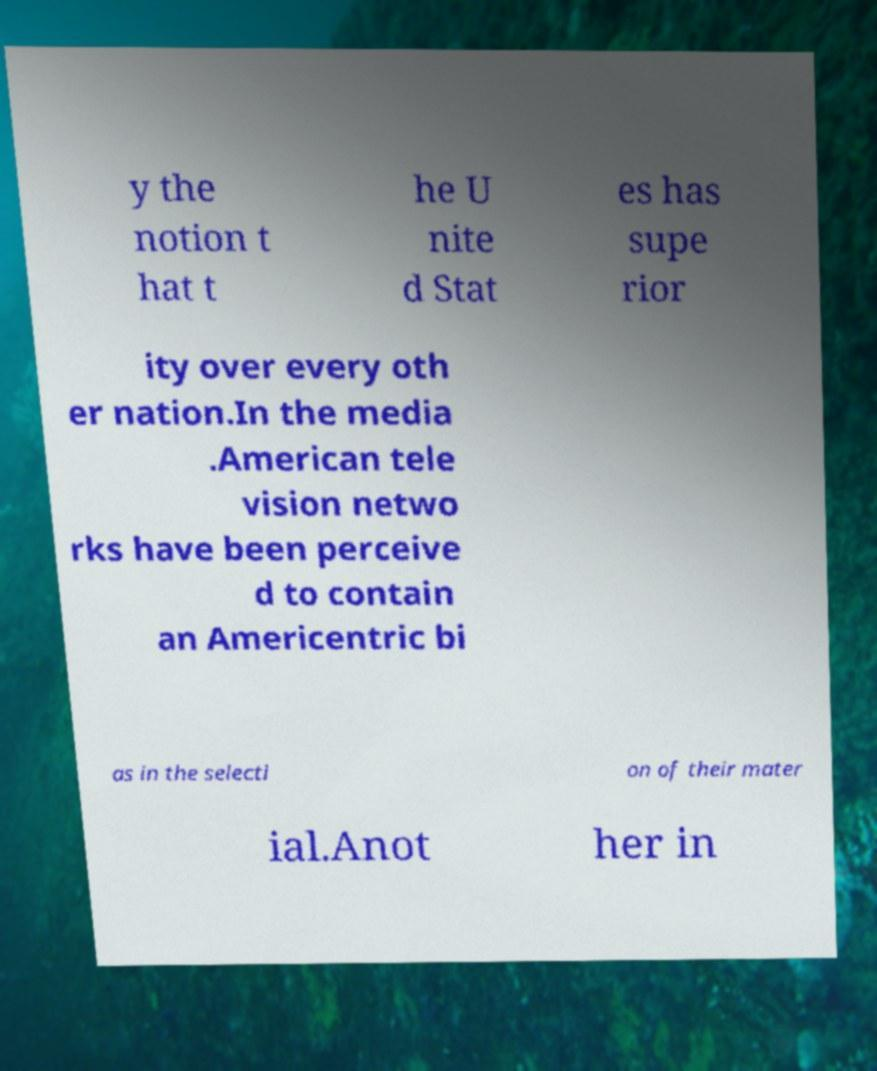For documentation purposes, I need the text within this image transcribed. Could you provide that? y the notion t hat t he U nite d Stat es has supe rior ity over every oth er nation.In the media .American tele vision netwo rks have been perceive d to contain an Americentric bi as in the selecti on of their mater ial.Anot her in 